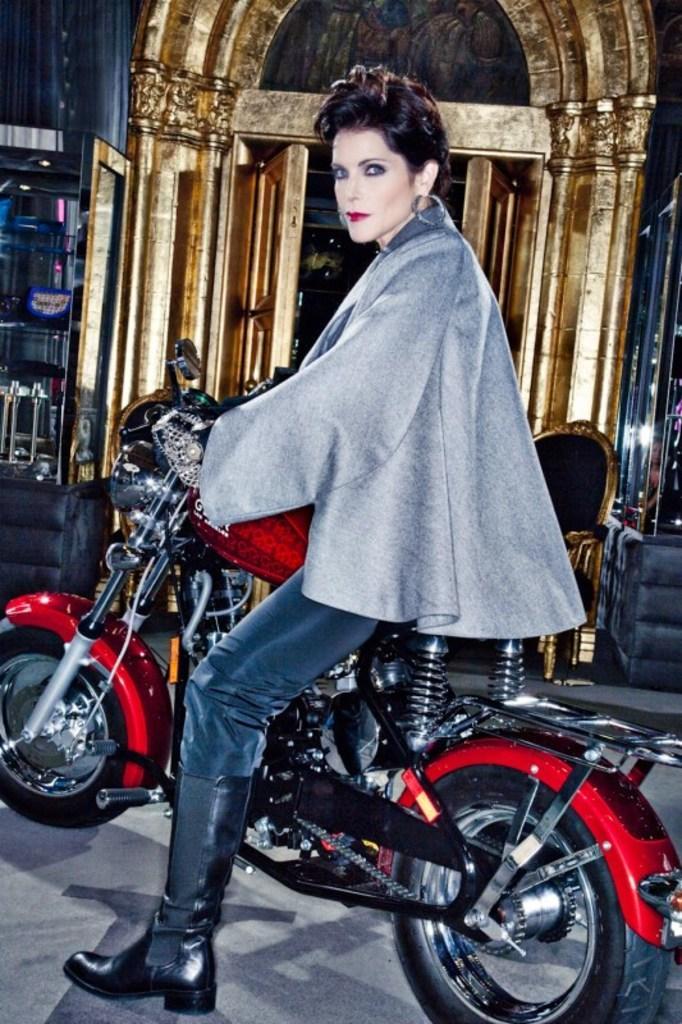Describe this image in one or two sentences. In this image we can see a woman sitting on a motorcycle. 